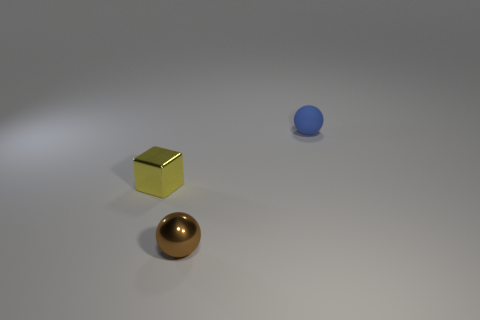Add 2 large blue metallic objects. How many objects exist? 5 Add 2 large metallic objects. How many large metallic objects exist? 2 Subtract 0 yellow cylinders. How many objects are left? 3 Subtract all balls. How many objects are left? 1 Subtract 1 balls. How many balls are left? 1 Subtract all yellow balls. Subtract all red blocks. How many balls are left? 2 Subtract all tiny brown spheres. Subtract all tiny red matte things. How many objects are left? 2 Add 2 tiny blue matte things. How many tiny blue matte things are left? 3 